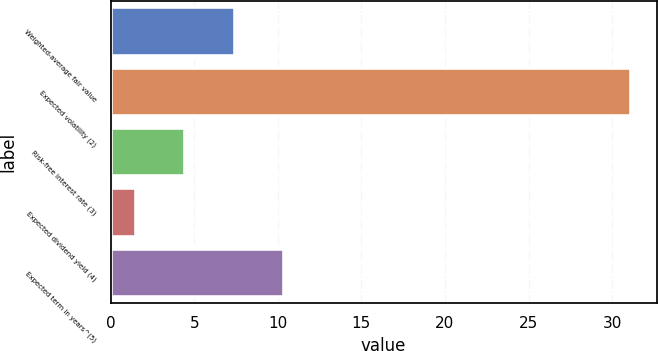Convert chart to OTSL. <chart><loc_0><loc_0><loc_500><loc_500><bar_chart><fcel>Weighted-average fair value<fcel>Expected volatility (2)<fcel>Risk-free interest rate (3)<fcel>Expected dividend yield (4)<fcel>Expected term in years^(5)<nl><fcel>7.42<fcel>31.1<fcel>4.46<fcel>1.5<fcel>10.38<nl></chart> 